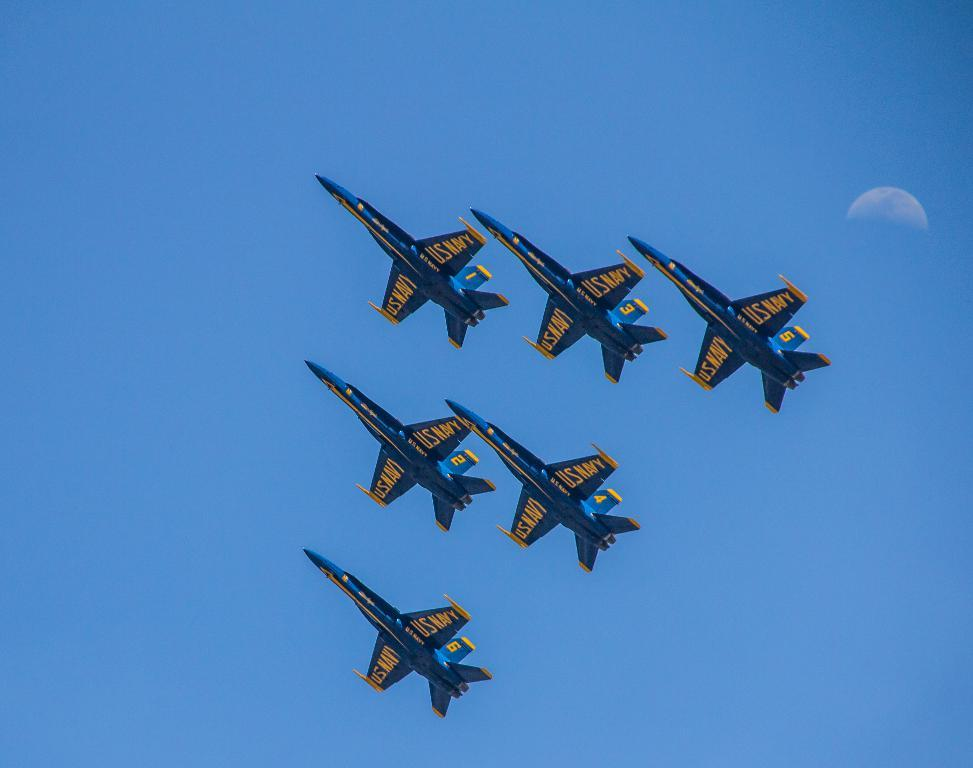What is happening in the sky in the image? There are planes flying in the air in the image. What can be seen in the background of the image? The sky is visible in the background of the image. What celestial body is visible in the sky? The moon is visible in the sky. What type of button can be seen on the moon in the image? There is no button present on the moon in the image. 